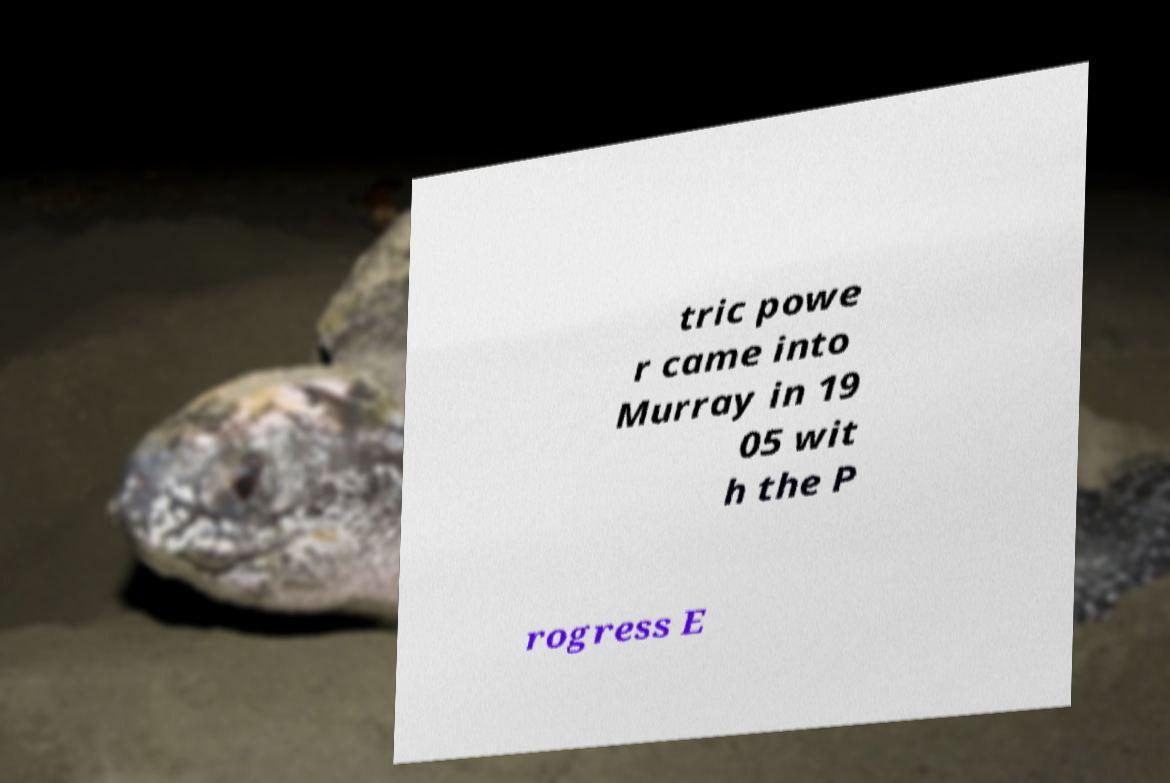Can you accurately transcribe the text from the provided image for me? tric powe r came into Murray in 19 05 wit h the P rogress E 